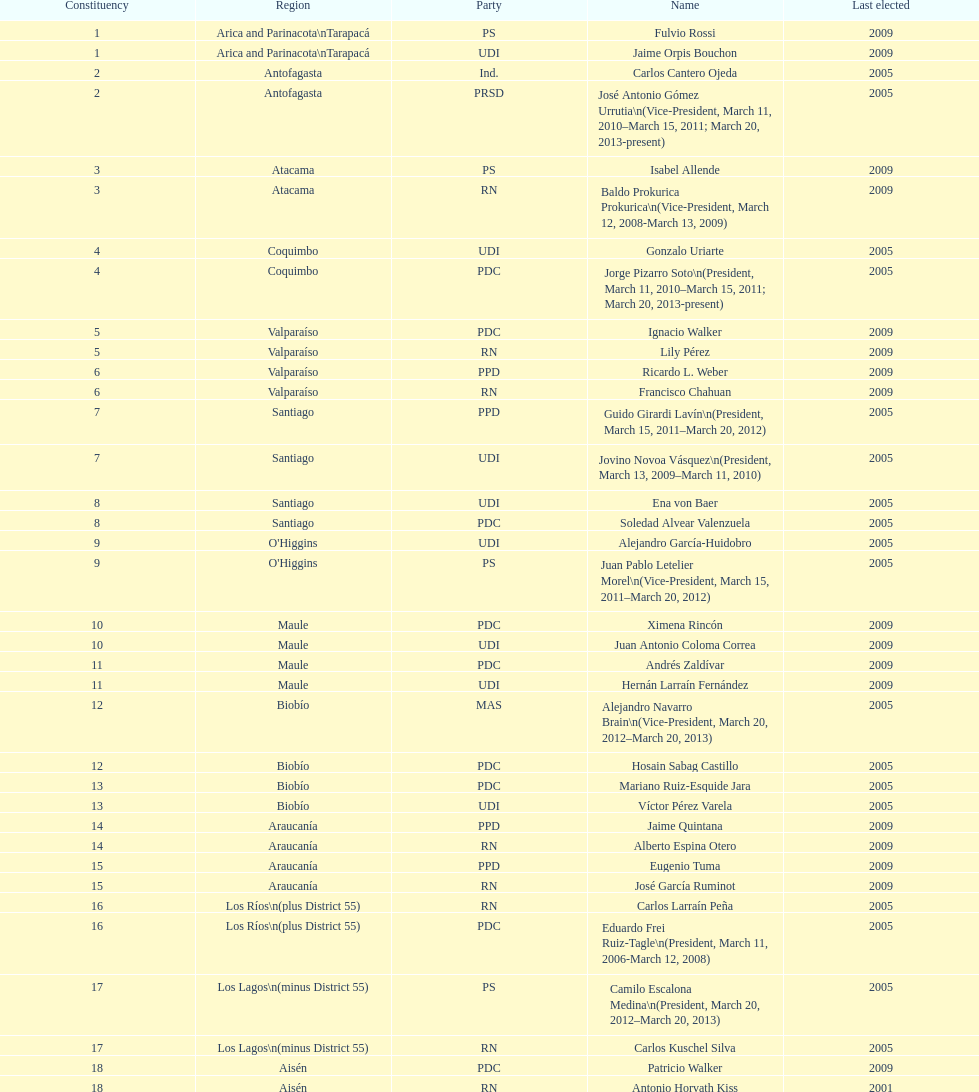How long was baldo prokurica prokurica vice-president? 1 year. 